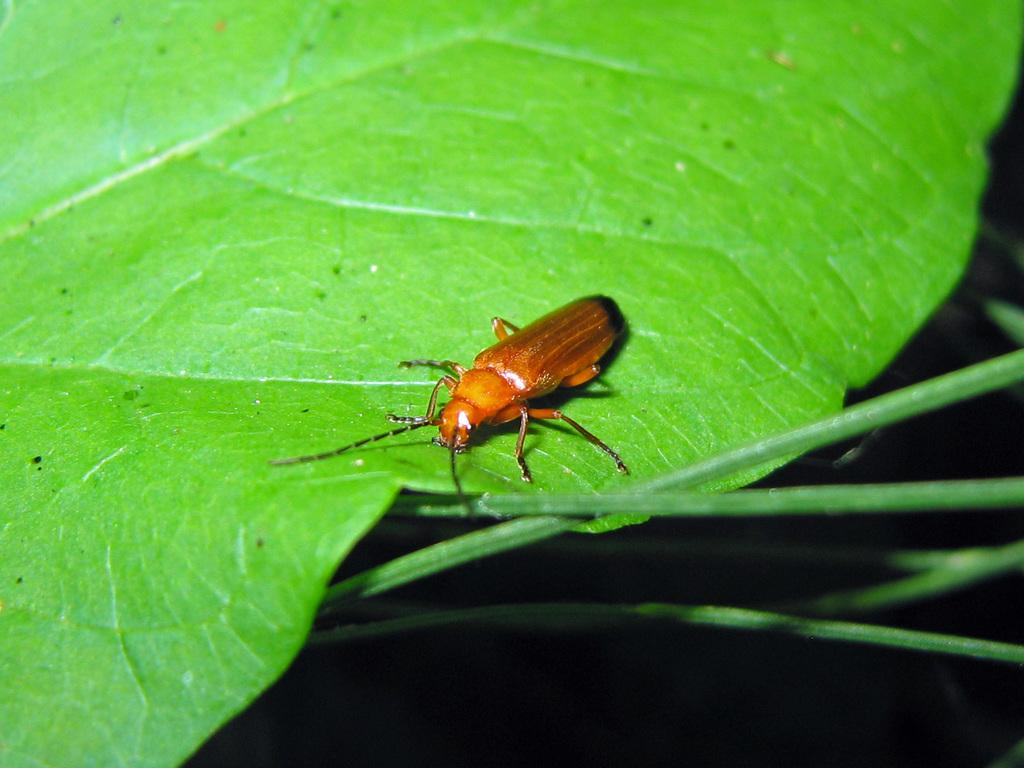What is present on the leaf in the image? There is an insect on a leaf in the image. What can be seen in the background of the image? There are leaves visible in the background of the image. What type of zinc is the carriage made of in the image? There is no carriage present in the image, and therefore no such material can be identified. 